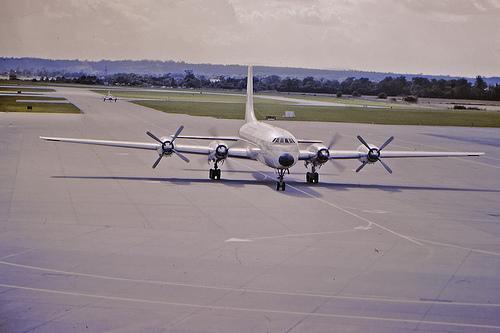How many propellers on the plane?
Give a very brief answer. 4. How many airplanes are there?
Give a very brief answer. 2. How many panels in the cockpit window?
Give a very brief answer. 6. How many wheels on the plane?
Give a very brief answer. 6. 